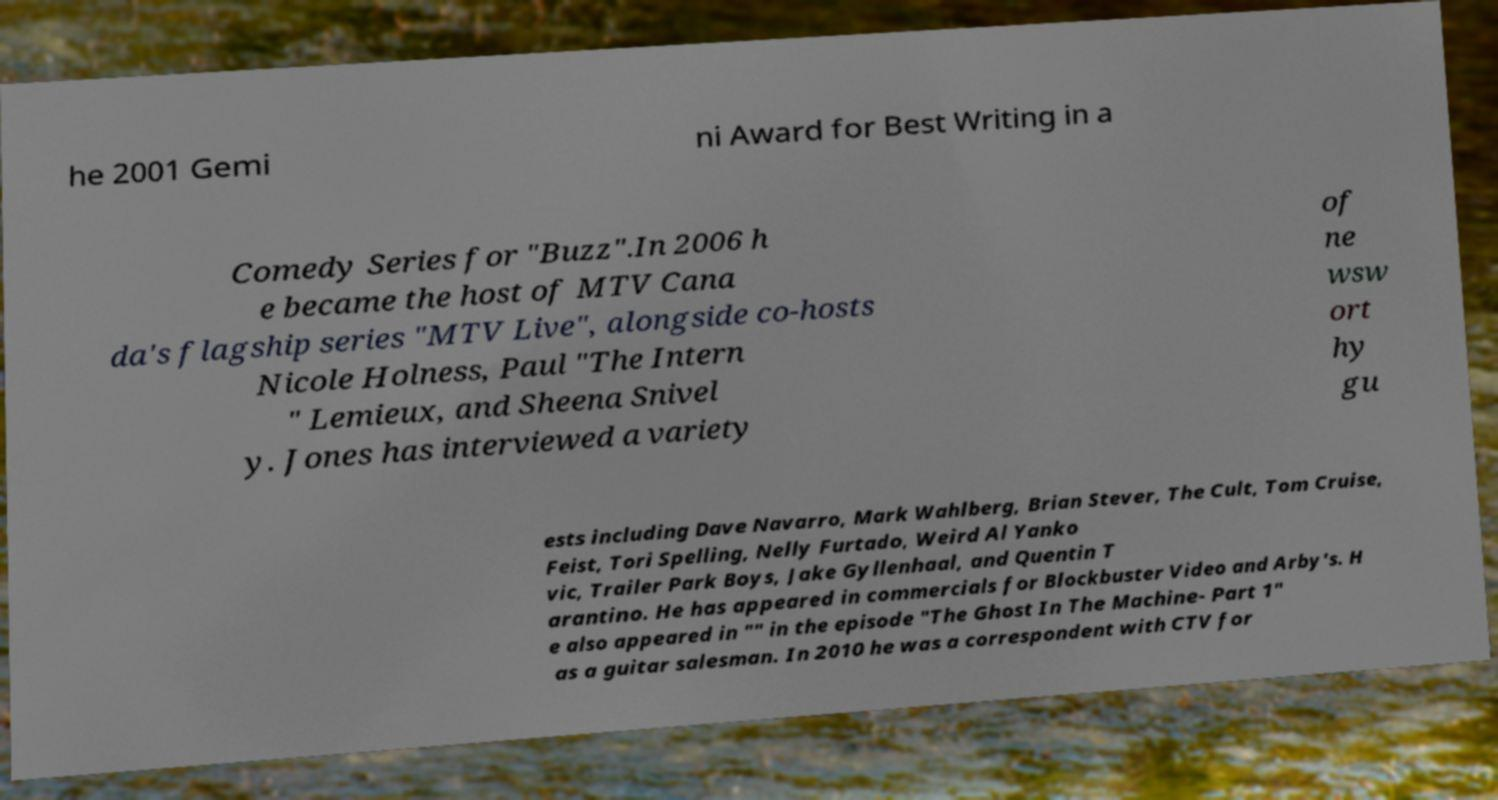Please identify and transcribe the text found in this image. he 2001 Gemi ni Award for Best Writing in a Comedy Series for "Buzz".In 2006 h e became the host of MTV Cana da's flagship series "MTV Live", alongside co-hosts Nicole Holness, Paul "The Intern " Lemieux, and Sheena Snivel y. Jones has interviewed a variety of ne wsw ort hy gu ests including Dave Navarro, Mark Wahlberg, Brian Stever, The Cult, Tom Cruise, Feist, Tori Spelling, Nelly Furtado, Weird Al Yanko vic, Trailer Park Boys, Jake Gyllenhaal, and Quentin T arantino. He has appeared in commercials for Blockbuster Video and Arby's. H e also appeared in "" in the episode "The Ghost In The Machine- Part 1" as a guitar salesman. In 2010 he was a correspondent with CTV for 